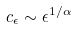Convert formula to latex. <formula><loc_0><loc_0><loc_500><loc_500>c _ { \epsilon } \sim \epsilon ^ { 1 / \alpha }</formula> 